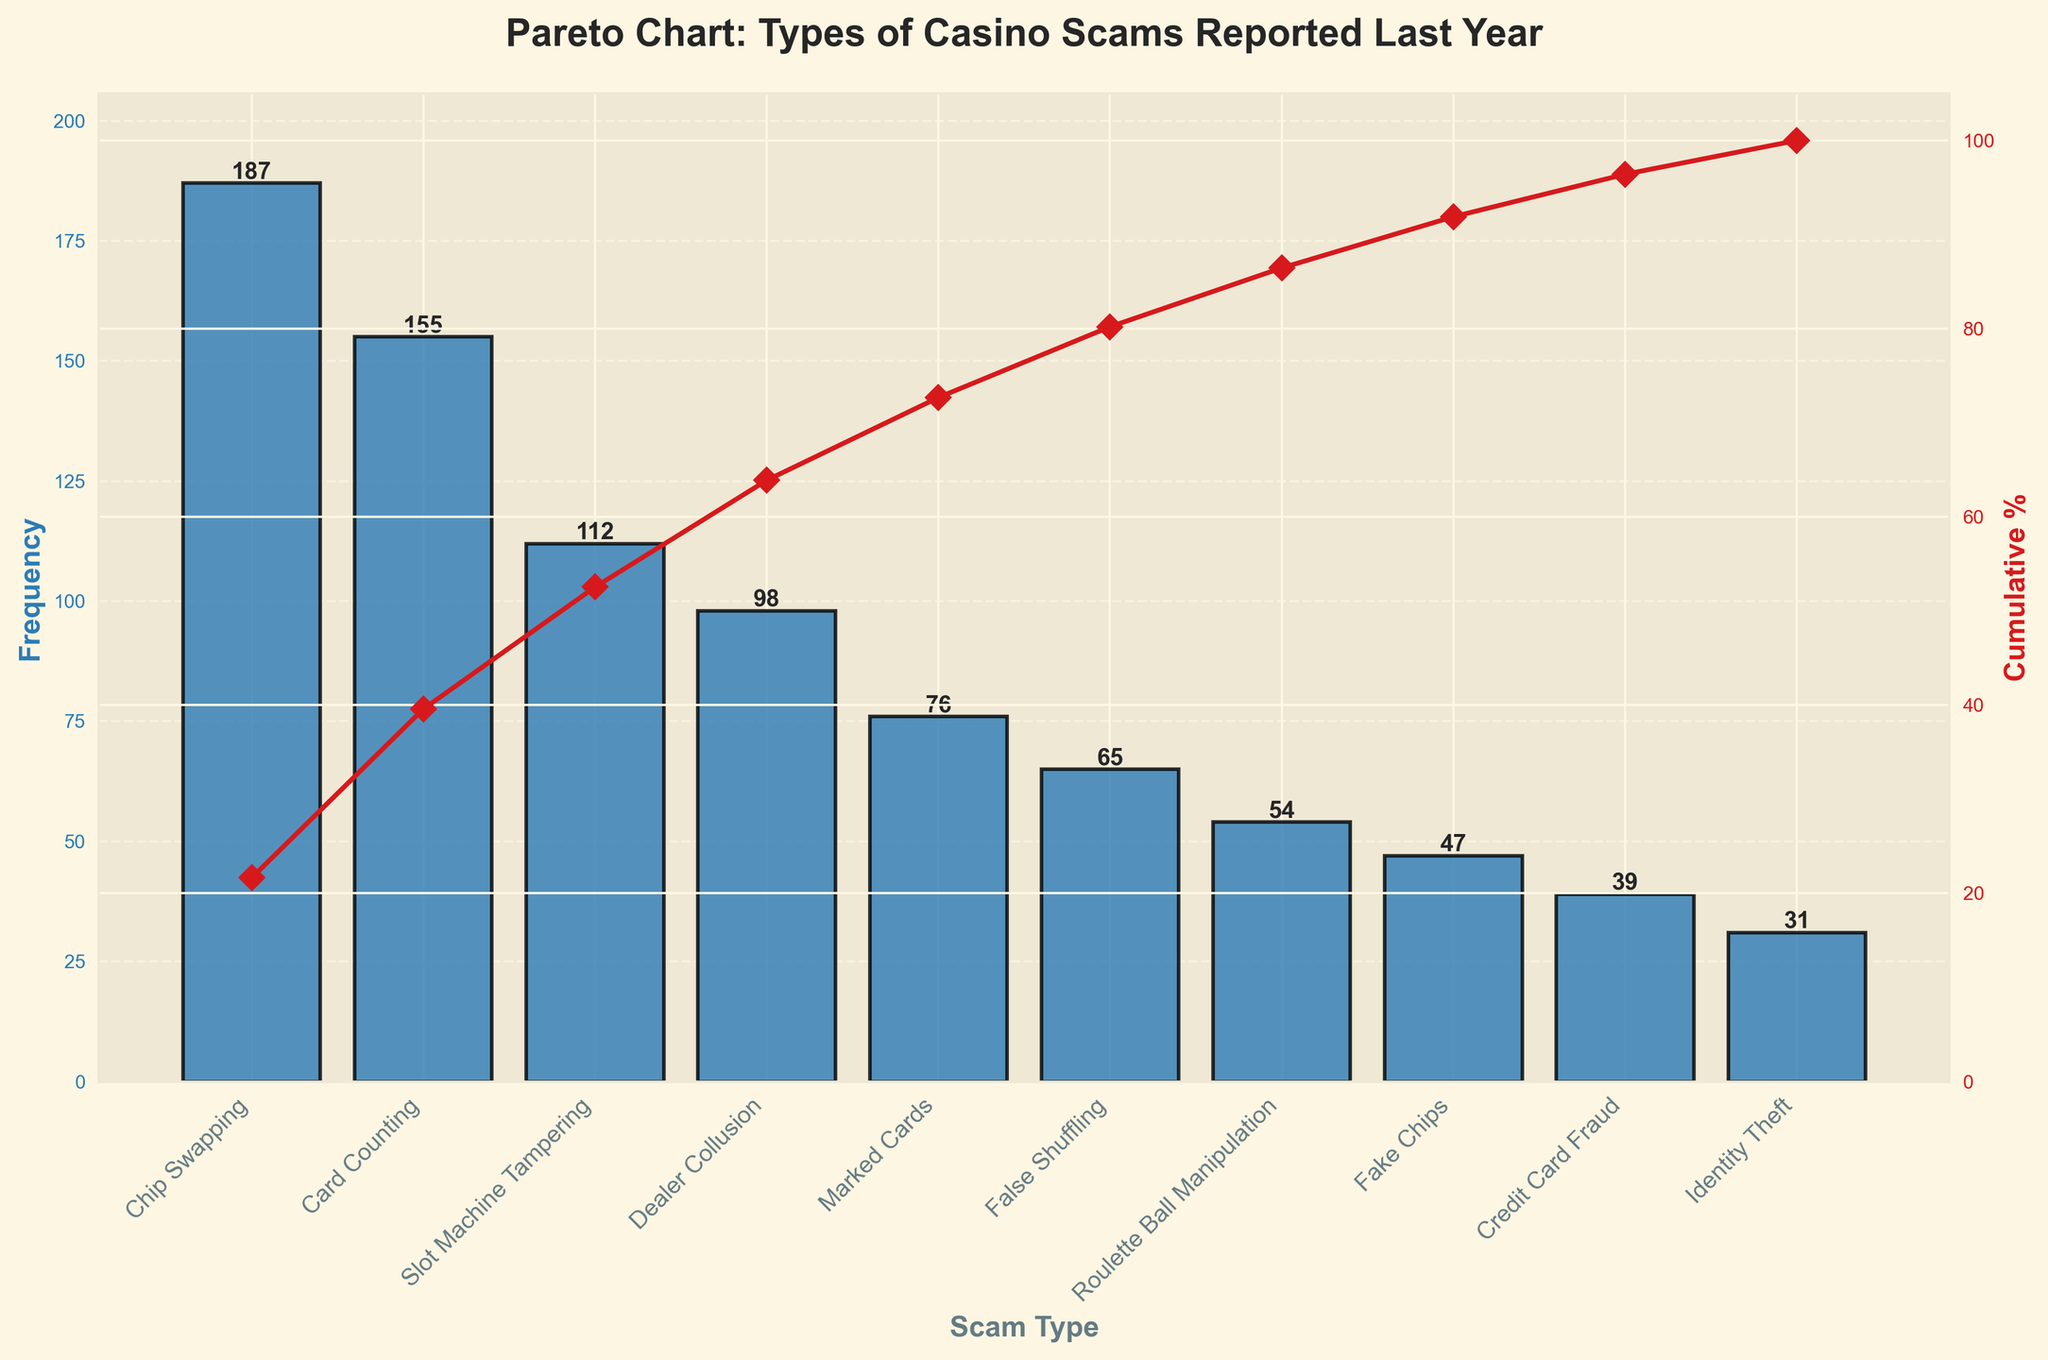What's the most frequent scam type reported in the last year? The most frequent scam type can be identified by the highest bar in the chart. The tallest bar corresponds to the 'Chip Swapping' scam type.
Answer: Chip Swapping How many different scam types are reported in the figure? The scam types are listed along the x-axis, and counting the labels gives the total number of scam types. There are 10 different labels.
Answer: 10 What's the cumulative percentage for Slot Machine Tampering? On the secondary y-axis (right side) of the chart, the line plot shows cumulative percentages matched to each scam type. For 'Slot Machine Tampering,' the cumulative percentage is around 65%.
Answer: 65% What is the total frequency of Card Counting, Dealer Collusion, and False Shuffling? To find the total frequency, we sum the individual frequencies of 'Card Counting,' 'Dealer Collusion,' and 'False Shuffling.' Their frequencies are 155, 98, and 65, respectively. Summing these gives 155 + 98 + 65 = 318.
Answer: 318 Which scam type has a higher frequency: Marked Cards or Fake Chips? By comparing the heights of 'Marked Cards' and 'Fake Chips' bars, 'Marked Cards' has a higher frequency of 76 compared to 47 for 'Fake Chips'.
Answer: Marked Cards At what cumulative percentage do the first three scam types in frequency reach? By identifying the first three scam types by frequency ('Chip Swapping,' 'Card Counting,' 'Slot Machine Tampering'), their cumulative percentages are summed: ‘Chip Swapping’ (around 23%), ‘Card Counting’ (around 42%), and ‘Slot Machine Tampering’ (around 65%). Thus, the cumulative percentage is approximately 65%.
Answer: 65% What is the combined percentage of 'Roulette Ball Manipulation' and 'Identity Theft'? From the cumulative percentage line, subtract the cumulative percentage of the data point before 'Roulette Ball Manipulation' from that of 'Identity Theft' to get the percentages of 'Roulette Ball Manipulation' and 'Identity Theft' individually and add them. ‘Roulette Ball Manipulation’ (7%) and ‘Identity Theft’ (4%) lead to a total of 7 + 4 = 11%.
Answer: 11% Which scam type contributes less than 10% to the cumulative percentage? Each scam type's contribution can be read off the cumulative percentage line. The scam types that contribute less than 10% individually are 'Credit Card Fraud' and 'Identity Theft,' reading their percentages from the cumulative percentage line as both are below the 10% mark.
Answer: Credit Card Fraud and Identity Theft How does the frequency of 'Dealer Collusion' compare to that of 'Slot Machine Tampering'? By comparing their frequencies directly from the bars, 'Slot Machine Tampering' has a higher frequency (112) than 'Dealer Collusion' (98).
Answer: Slot Machine Tampering is higher than Dealer Collusion What's the proportion of 'Card Counting' to the total number of reported scams? Calculate the total number of all reported scams by summing the frequencies of all scam types: 187+155+112+98+76+65+54+47+39+31 = 864. The proportion would be the frequency of 'Card Counting' divided by the total, 155/864. Simplifying gives approximately 0.179 or 17.9%.
Answer: 17.9% 